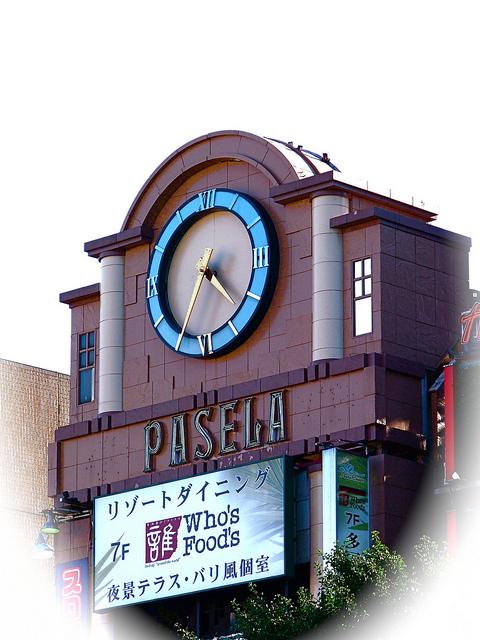What does the sign say?
Answer briefly. Who's foods. What time does this clock have?
Be succinct. 4:35. What kind of characters are in the sign?
Quick response, please. Chinese. 